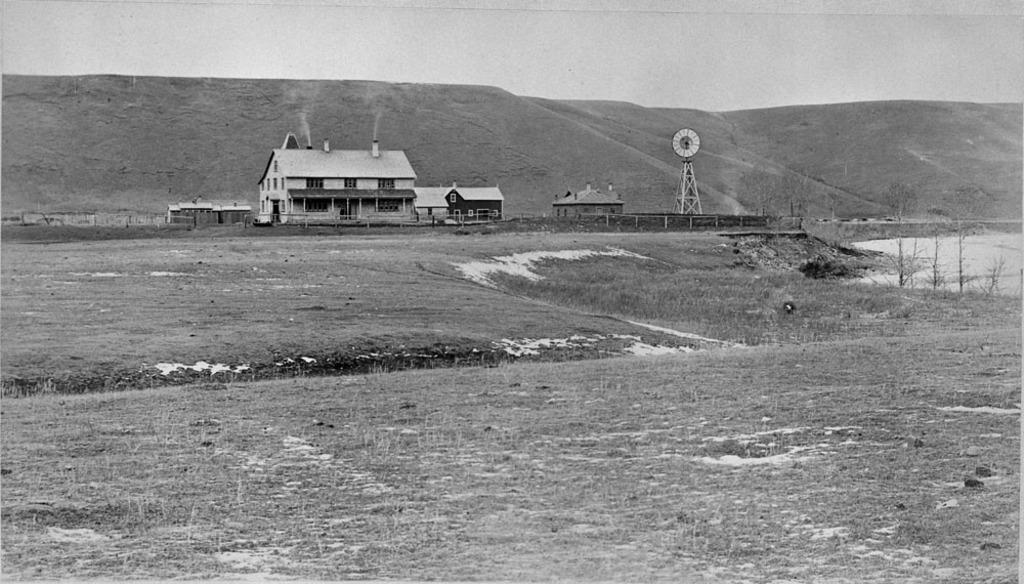What type of vegetation is at the bottom of the image? There is grass at the bottom of the image. What structures are located in the middle of the image? There are buildings in the middle of the image. What is behind the buildings in the image? There is a hill behind the buildings. What is visible at the top of the image? The sky is visible at the top of the image. Where is the comb placed in the image? There is no comb present in the image. What type of vase can be seen on the hill in the image? There is no vase present on the hill in the image. 